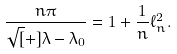<formula> <loc_0><loc_0><loc_500><loc_500>\frac { n \pi } { \sqrt { [ } + ] { \lambda - \lambda _ { 0 } } } = 1 + \frac { 1 } { n } \ell ^ { 2 } _ { n } .</formula> 